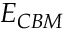<formula> <loc_0><loc_0><loc_500><loc_500>E _ { C B M }</formula> 